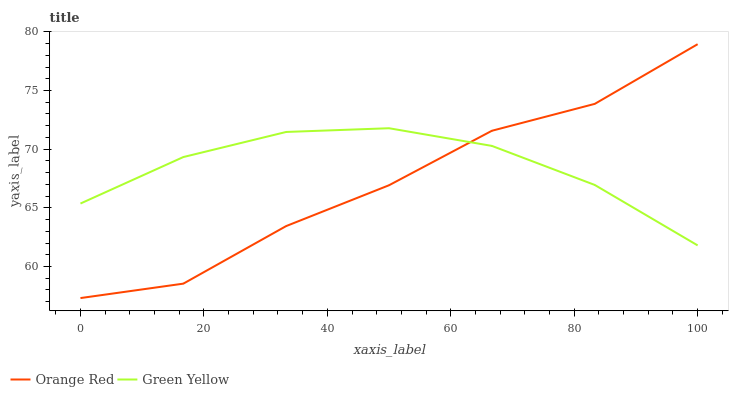Does Orange Red have the minimum area under the curve?
Answer yes or no. Yes. Does Green Yellow have the maximum area under the curve?
Answer yes or no. Yes. Does Orange Red have the maximum area under the curve?
Answer yes or no. No. Is Green Yellow the smoothest?
Answer yes or no. Yes. Is Orange Red the roughest?
Answer yes or no. Yes. Is Orange Red the smoothest?
Answer yes or no. No. Does Orange Red have the lowest value?
Answer yes or no. Yes. Does Orange Red have the highest value?
Answer yes or no. Yes. Does Green Yellow intersect Orange Red?
Answer yes or no. Yes. Is Green Yellow less than Orange Red?
Answer yes or no. No. Is Green Yellow greater than Orange Red?
Answer yes or no. No. 